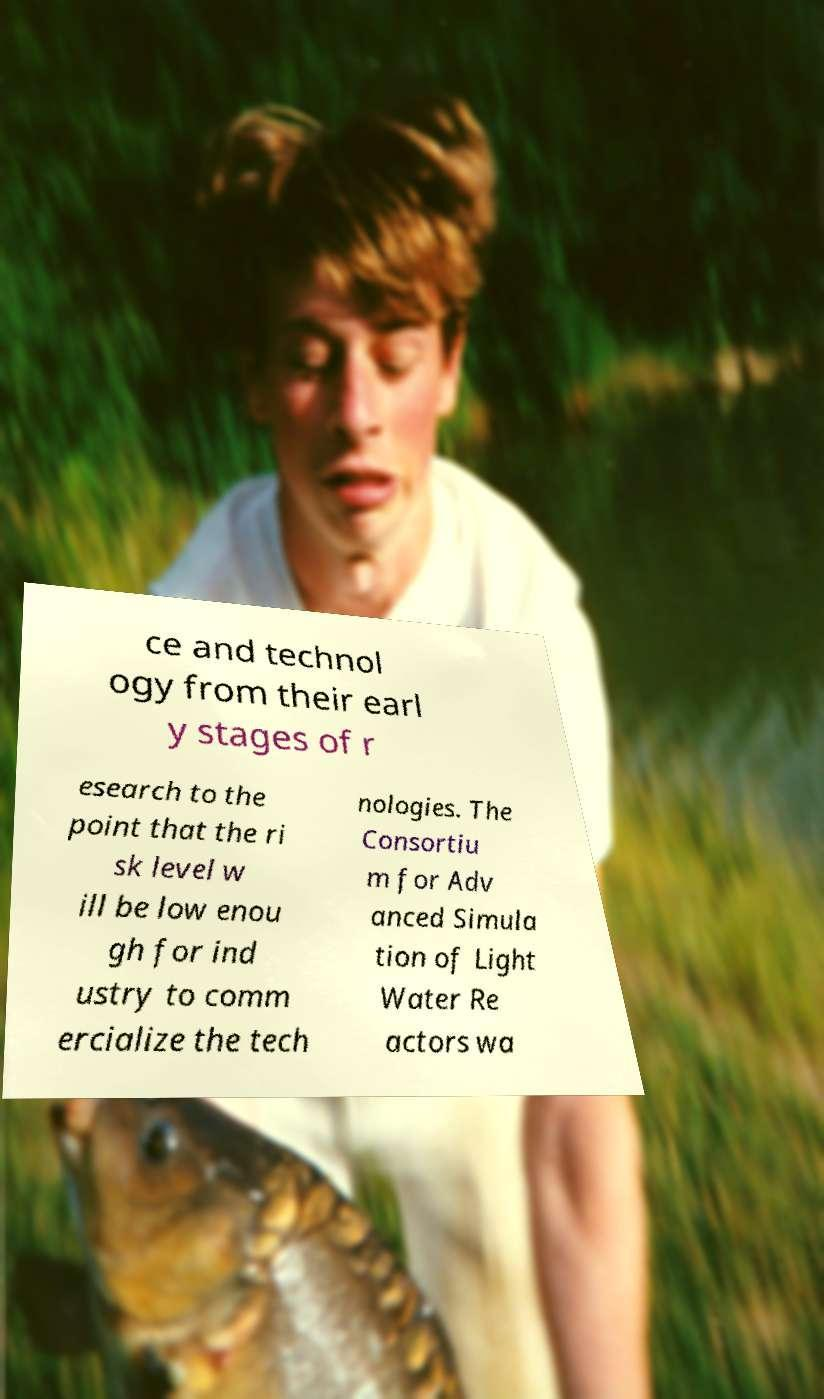Please read and relay the text visible in this image. What does it say? ce and technol ogy from their earl y stages of r esearch to the point that the ri sk level w ill be low enou gh for ind ustry to comm ercialize the tech nologies. The Consortiu m for Adv anced Simula tion of Light Water Re actors wa 